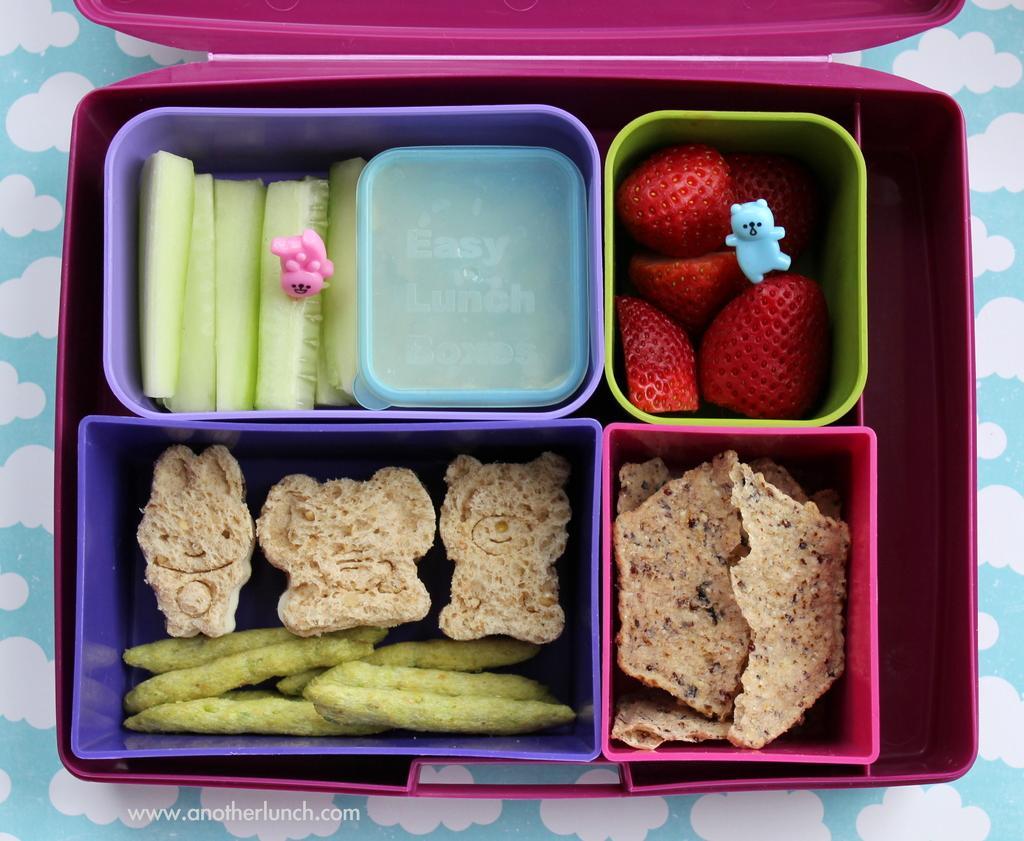Could you give a brief overview of what you see in this image? In this picture we can see a pink color box. In a box we can see different containers with food items. We can see pink and blue toys. 